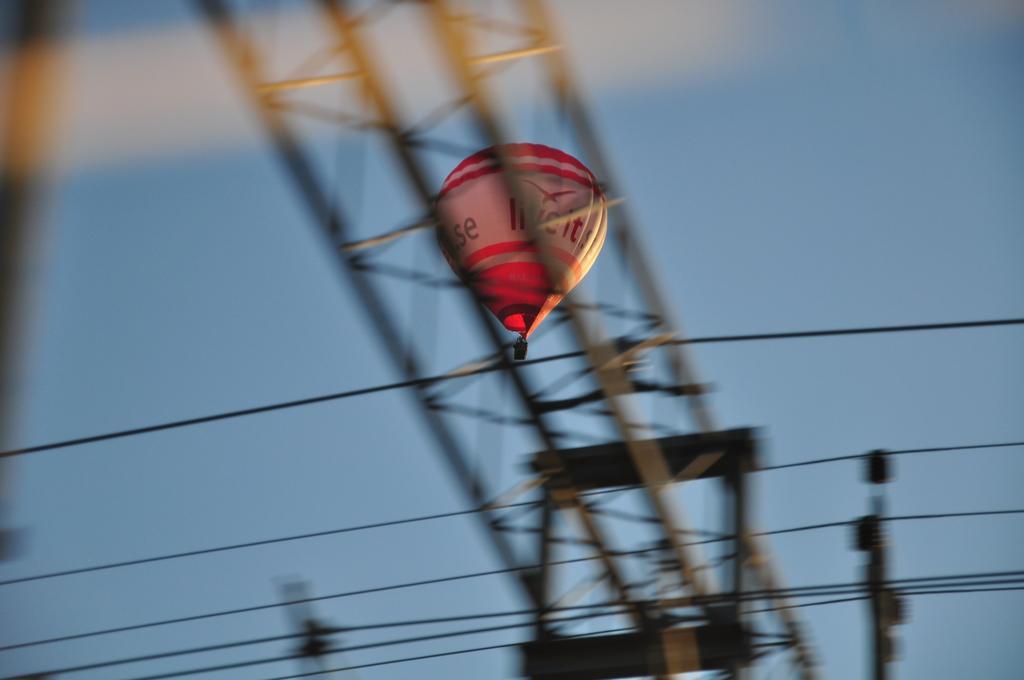In one or two sentences, can you explain what this image depicts? In this image there is a hot air balloon in the air. There is text on the balloon. In the foreground there are metal rods and cables. At the bottom there are poles. In the background there is the sky. 